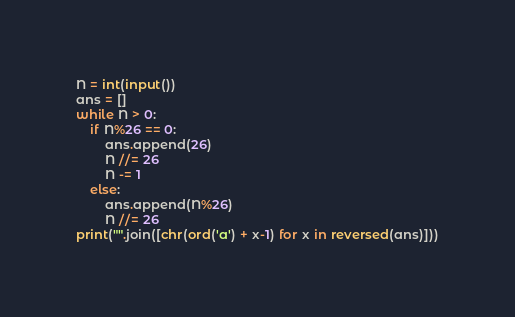<code> <loc_0><loc_0><loc_500><loc_500><_Python_>N = int(input())
ans = []
while N > 0:
    if N%26 == 0:
        ans.append(26)
        N //= 26
        N -= 1
    else:
        ans.append(N%26)
        N //= 26
print("".join([chr(ord('a') + x-1) for x in reversed(ans)]))
</code> 